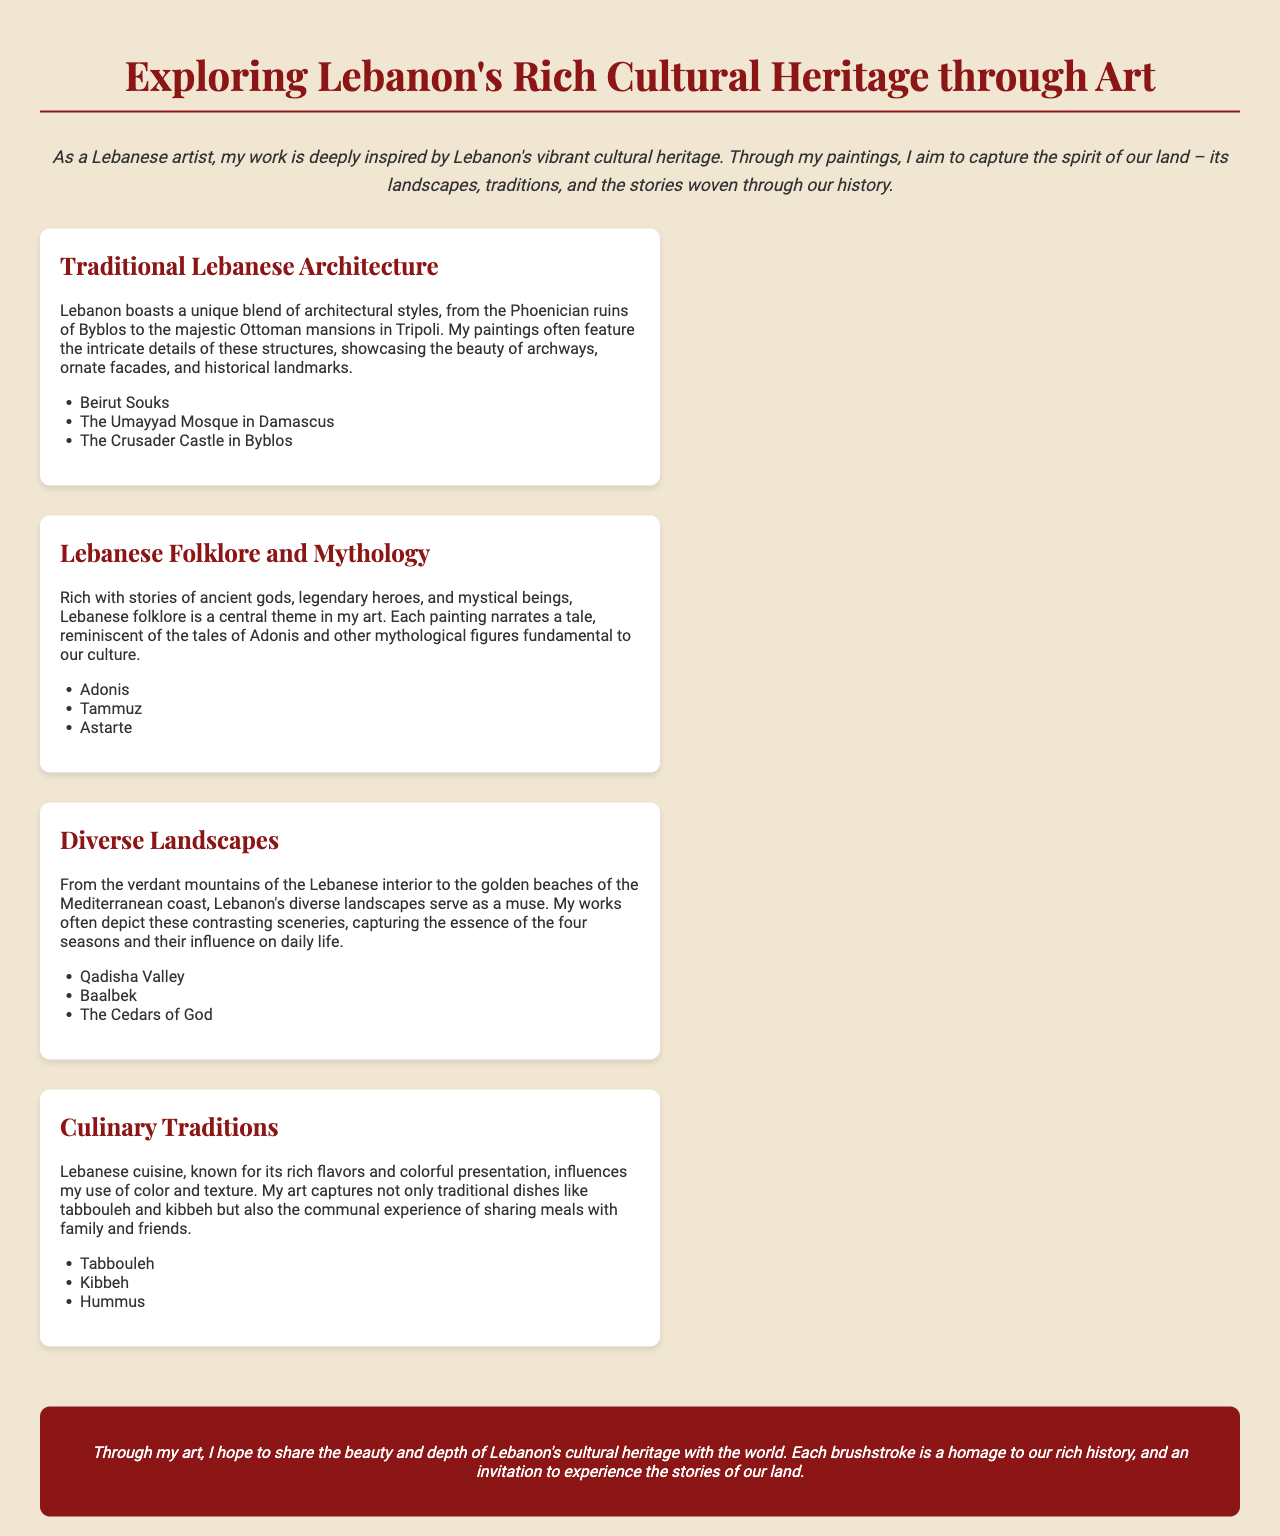What is the title of the brochure? The title of the brochure is the main header presented at the top of the document.
Answer: Exploring Lebanon's Rich Cultural Heritage through Art What architectural styles are mentioned? The document lists different types of architecture as part of Lebanese cultural heritage.
Answer: Phoenician ruins, Ottoman mansions Who are some characters from Lebanese folklore? The document specifically names figures from Lebanese mythology relevant to the artist's paintings.
Answer: Adonis, Tammuz, Astarte What landscapes inspire the artist's work? The document describes various landscapes that influence the artist's paintings.
Answer: Verdant mountains, golden beaches Which traditional dish is highlighted for its presentation? The document mentions traditional dishes that are significant in Lebanese cuisine, focusing on a specific aspect.
Answer: Tabbouleh What is the artist's aim with their paintings? The document articulates the artist's intention behind their work, reflecting broader cultural themes.
Answer: To share the beauty and depth of Lebanon's cultural heritage How is color and texture influenced in the artist's work? The document references the relationship between culinary traditions and the artist's use of artistic elements.
Answer: Rich flavors and colorful presentation What is the significance of communal meals? The document emphasizes the communal aspect of Lebanese cuisine and its influence on the artist's perception of culture.
Answer: Sharing meals with family and friends 